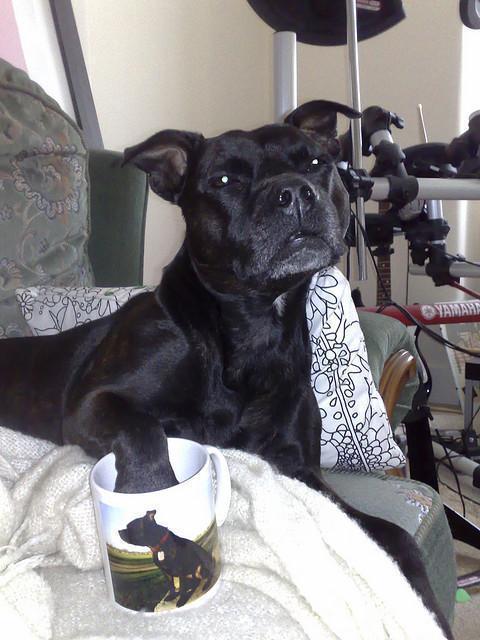How many dogs are there?
Give a very brief answer. 2. 